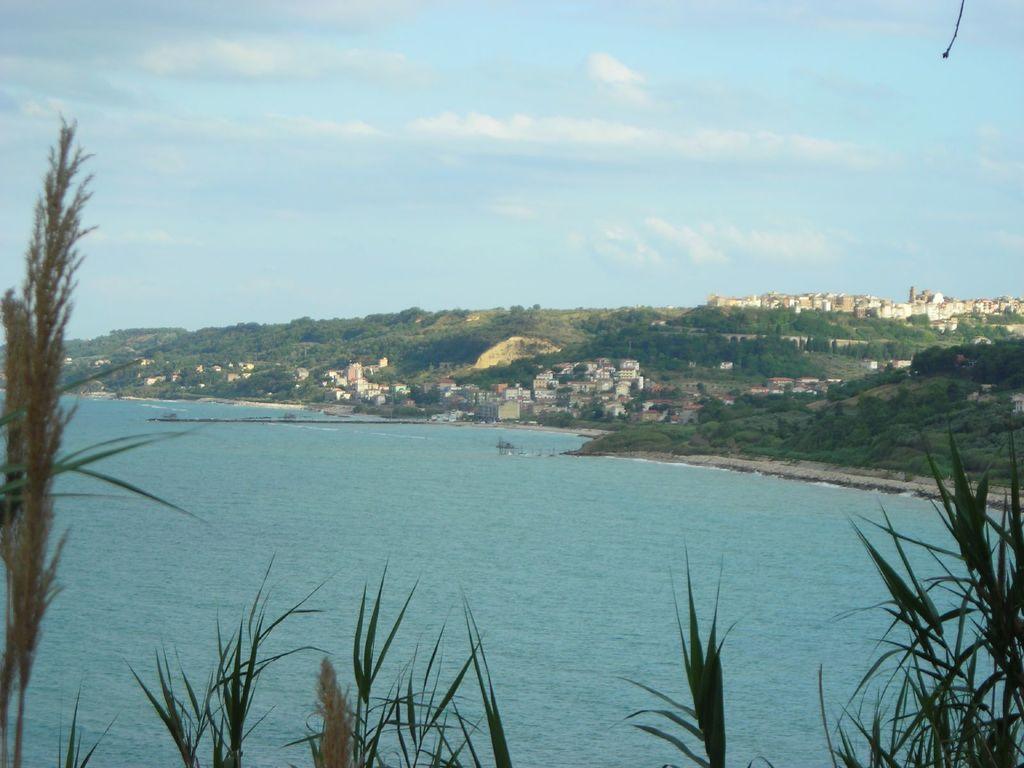In one or two sentences, can you explain what this image depicts? In this image in the foreground there are plants. Here there is a water body. In the background there are buildings, hills, trees. The sky is cloudy. 